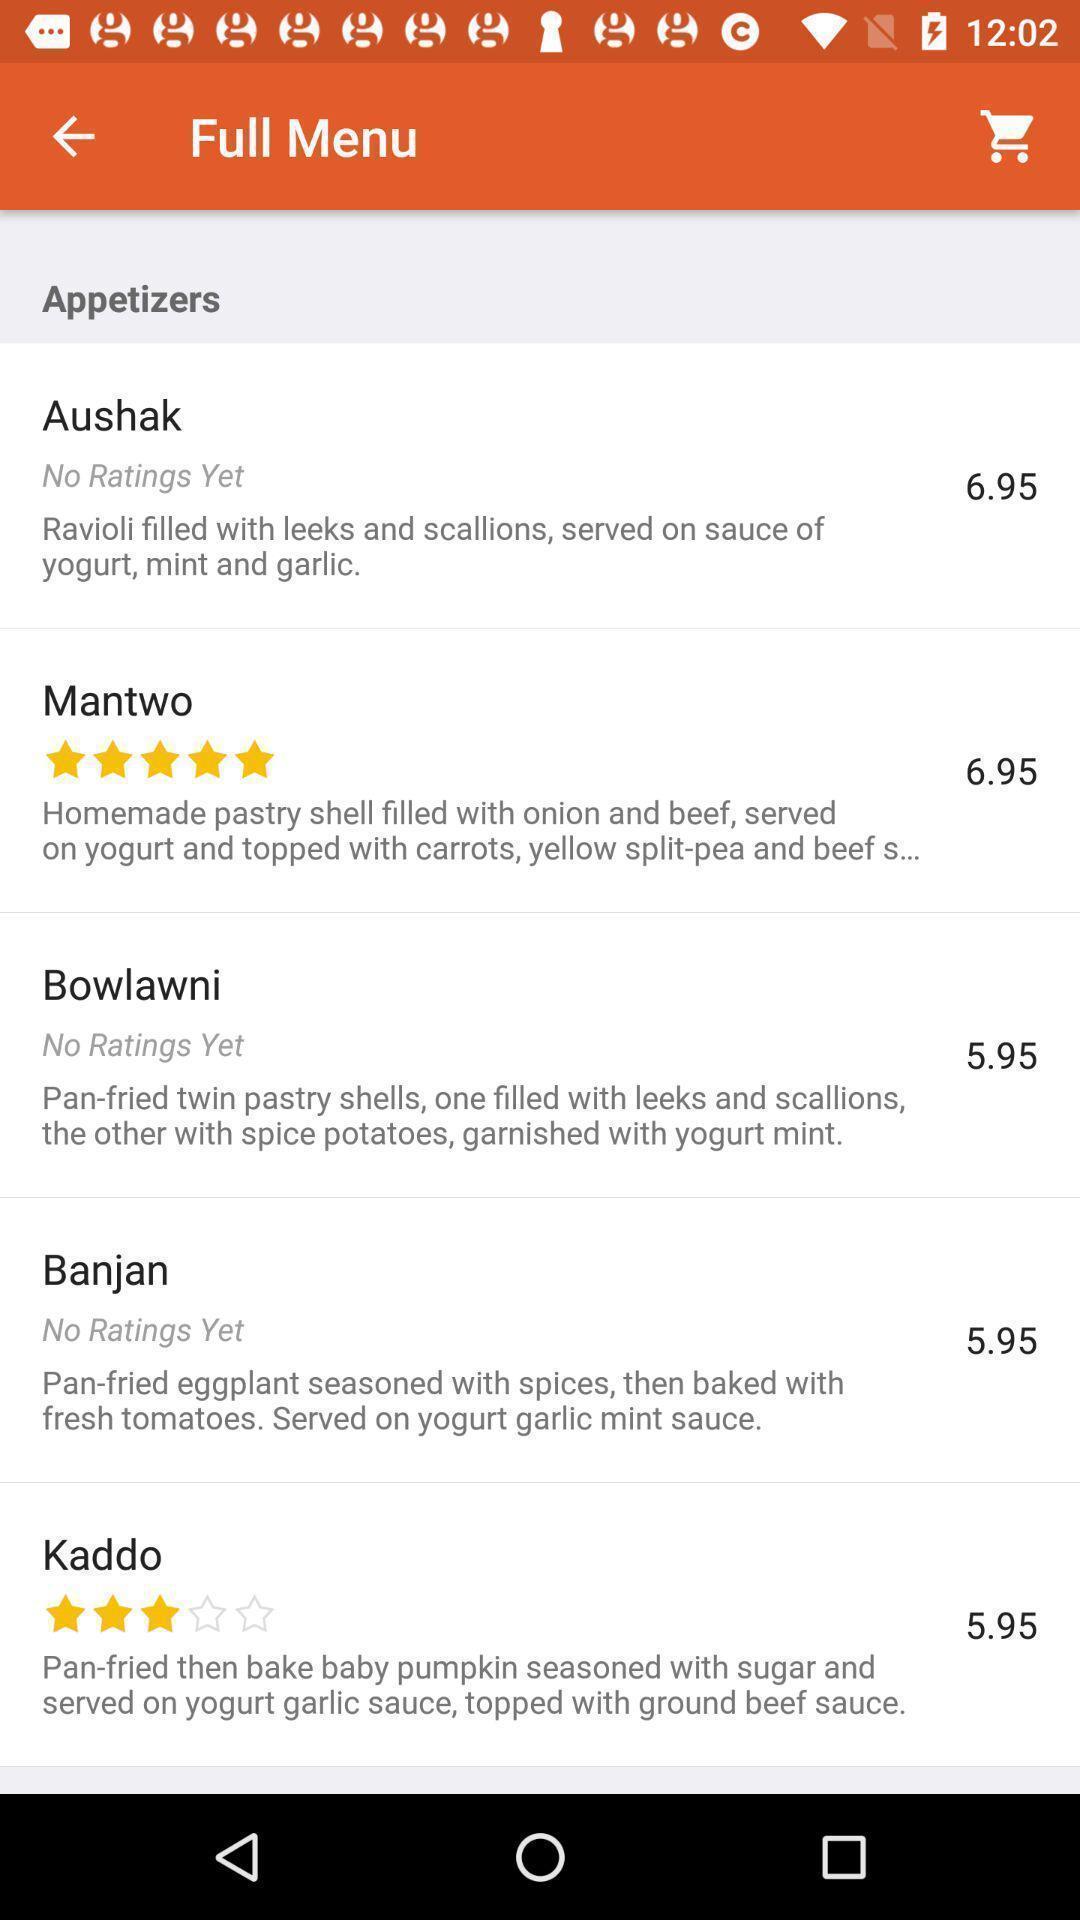Explain what's happening in this screen capture. Screen displaying the menu of appetizers. 